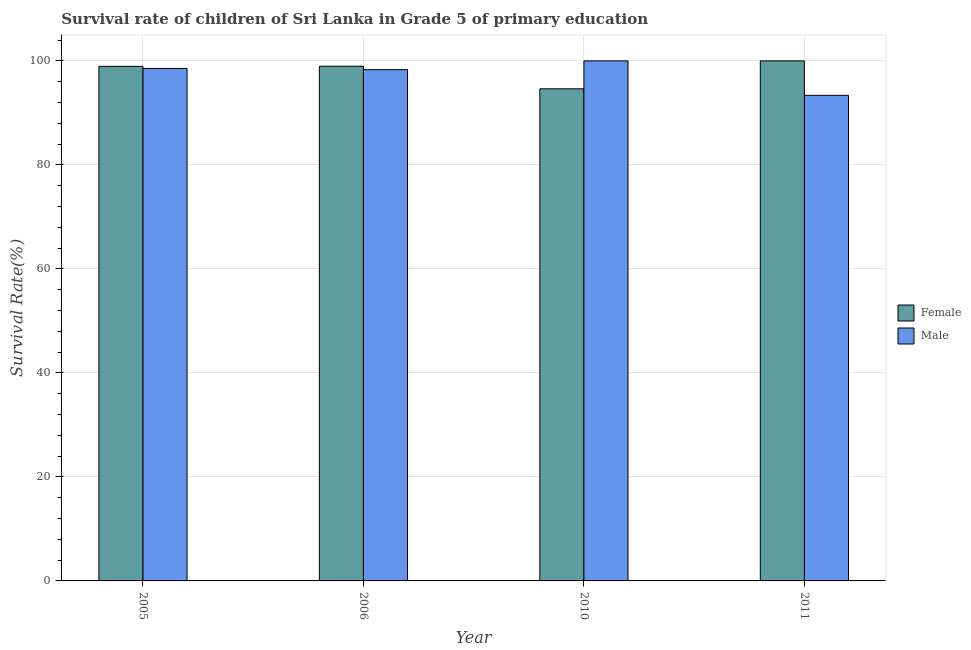How many different coloured bars are there?
Your answer should be compact. 2. How many groups of bars are there?
Provide a short and direct response. 4. Are the number of bars on each tick of the X-axis equal?
Make the answer very short. Yes. How many bars are there on the 1st tick from the right?
Provide a succinct answer. 2. What is the label of the 1st group of bars from the left?
Give a very brief answer. 2005. What is the survival rate of female students in primary education in 2010?
Offer a terse response. 94.63. Across all years, what is the minimum survival rate of male students in primary education?
Keep it short and to the point. 93.38. In which year was the survival rate of female students in primary education minimum?
Ensure brevity in your answer.  2010. What is the total survival rate of female students in primary education in the graph?
Keep it short and to the point. 392.54. What is the difference between the survival rate of male students in primary education in 2005 and that in 2010?
Make the answer very short. -1.47. What is the difference between the survival rate of female students in primary education in 2011 and the survival rate of male students in primary education in 2006?
Your response must be concise. 1.03. What is the average survival rate of female students in primary education per year?
Keep it short and to the point. 98.14. What is the ratio of the survival rate of male students in primary education in 2005 to that in 2006?
Keep it short and to the point. 1. Is the survival rate of male students in primary education in 2005 less than that in 2006?
Provide a succinct answer. No. Is the difference between the survival rate of male students in primary education in 2005 and 2011 greater than the difference between the survival rate of female students in primary education in 2005 and 2011?
Provide a succinct answer. No. What is the difference between the highest and the second highest survival rate of male students in primary education?
Offer a very short reply. 1.47. What is the difference between the highest and the lowest survival rate of male students in primary education?
Your answer should be compact. 6.62. In how many years, is the survival rate of female students in primary education greater than the average survival rate of female students in primary education taken over all years?
Your answer should be very brief. 3. Is the sum of the survival rate of female students in primary education in 2005 and 2011 greater than the maximum survival rate of male students in primary education across all years?
Give a very brief answer. Yes. What does the 2nd bar from the left in 2011 represents?
Your answer should be compact. Male. How many bars are there?
Ensure brevity in your answer.  8. Are all the bars in the graph horizontal?
Provide a short and direct response. No. How many years are there in the graph?
Make the answer very short. 4. What is the difference between two consecutive major ticks on the Y-axis?
Provide a succinct answer. 20. Are the values on the major ticks of Y-axis written in scientific E-notation?
Ensure brevity in your answer.  No. Does the graph contain grids?
Make the answer very short. Yes. What is the title of the graph?
Your answer should be very brief. Survival rate of children of Sri Lanka in Grade 5 of primary education. Does "Register a property" appear as one of the legend labels in the graph?
Ensure brevity in your answer.  No. What is the label or title of the Y-axis?
Provide a short and direct response. Survival Rate(%). What is the Survival Rate(%) of Female in 2005?
Your response must be concise. 98.94. What is the Survival Rate(%) in Male in 2005?
Your answer should be very brief. 98.53. What is the Survival Rate(%) of Female in 2006?
Offer a very short reply. 98.97. What is the Survival Rate(%) of Male in 2006?
Offer a terse response. 98.31. What is the Survival Rate(%) in Female in 2010?
Make the answer very short. 94.63. What is the Survival Rate(%) of Female in 2011?
Keep it short and to the point. 100. What is the Survival Rate(%) in Male in 2011?
Offer a very short reply. 93.38. Across all years, what is the minimum Survival Rate(%) in Female?
Provide a short and direct response. 94.63. Across all years, what is the minimum Survival Rate(%) of Male?
Provide a short and direct response. 93.38. What is the total Survival Rate(%) of Female in the graph?
Provide a short and direct response. 392.54. What is the total Survival Rate(%) in Male in the graph?
Provide a short and direct response. 390.22. What is the difference between the Survival Rate(%) in Female in 2005 and that in 2006?
Provide a short and direct response. -0.02. What is the difference between the Survival Rate(%) in Male in 2005 and that in 2006?
Give a very brief answer. 0.22. What is the difference between the Survival Rate(%) in Female in 2005 and that in 2010?
Your answer should be very brief. 4.31. What is the difference between the Survival Rate(%) of Male in 2005 and that in 2010?
Offer a very short reply. -1.47. What is the difference between the Survival Rate(%) of Female in 2005 and that in 2011?
Provide a short and direct response. -1.06. What is the difference between the Survival Rate(%) of Male in 2005 and that in 2011?
Offer a very short reply. 5.16. What is the difference between the Survival Rate(%) in Female in 2006 and that in 2010?
Make the answer very short. 4.34. What is the difference between the Survival Rate(%) in Male in 2006 and that in 2010?
Offer a very short reply. -1.69. What is the difference between the Survival Rate(%) of Female in 2006 and that in 2011?
Make the answer very short. -1.03. What is the difference between the Survival Rate(%) of Male in 2006 and that in 2011?
Provide a short and direct response. 4.93. What is the difference between the Survival Rate(%) of Female in 2010 and that in 2011?
Your answer should be compact. -5.37. What is the difference between the Survival Rate(%) of Male in 2010 and that in 2011?
Give a very brief answer. 6.62. What is the difference between the Survival Rate(%) in Female in 2005 and the Survival Rate(%) in Male in 2006?
Your answer should be very brief. 0.63. What is the difference between the Survival Rate(%) in Female in 2005 and the Survival Rate(%) in Male in 2010?
Provide a short and direct response. -1.06. What is the difference between the Survival Rate(%) in Female in 2005 and the Survival Rate(%) in Male in 2011?
Your response must be concise. 5.57. What is the difference between the Survival Rate(%) of Female in 2006 and the Survival Rate(%) of Male in 2010?
Give a very brief answer. -1.03. What is the difference between the Survival Rate(%) in Female in 2006 and the Survival Rate(%) in Male in 2011?
Offer a terse response. 5.59. What is the difference between the Survival Rate(%) in Female in 2010 and the Survival Rate(%) in Male in 2011?
Provide a succinct answer. 1.25. What is the average Survival Rate(%) of Female per year?
Keep it short and to the point. 98.14. What is the average Survival Rate(%) of Male per year?
Provide a succinct answer. 97.56. In the year 2005, what is the difference between the Survival Rate(%) in Female and Survival Rate(%) in Male?
Your response must be concise. 0.41. In the year 2006, what is the difference between the Survival Rate(%) of Female and Survival Rate(%) of Male?
Make the answer very short. 0.66. In the year 2010, what is the difference between the Survival Rate(%) in Female and Survival Rate(%) in Male?
Your answer should be compact. -5.37. In the year 2011, what is the difference between the Survival Rate(%) of Female and Survival Rate(%) of Male?
Offer a very short reply. 6.62. What is the ratio of the Survival Rate(%) in Male in 2005 to that in 2006?
Give a very brief answer. 1. What is the ratio of the Survival Rate(%) of Female in 2005 to that in 2010?
Make the answer very short. 1.05. What is the ratio of the Survival Rate(%) of Male in 2005 to that in 2011?
Keep it short and to the point. 1.06. What is the ratio of the Survival Rate(%) in Female in 2006 to that in 2010?
Ensure brevity in your answer.  1.05. What is the ratio of the Survival Rate(%) in Male in 2006 to that in 2010?
Your answer should be compact. 0.98. What is the ratio of the Survival Rate(%) in Male in 2006 to that in 2011?
Make the answer very short. 1.05. What is the ratio of the Survival Rate(%) of Female in 2010 to that in 2011?
Your answer should be very brief. 0.95. What is the ratio of the Survival Rate(%) of Male in 2010 to that in 2011?
Offer a very short reply. 1.07. What is the difference between the highest and the second highest Survival Rate(%) in Female?
Your answer should be very brief. 1.03. What is the difference between the highest and the second highest Survival Rate(%) of Male?
Offer a very short reply. 1.47. What is the difference between the highest and the lowest Survival Rate(%) in Female?
Make the answer very short. 5.37. What is the difference between the highest and the lowest Survival Rate(%) in Male?
Make the answer very short. 6.62. 